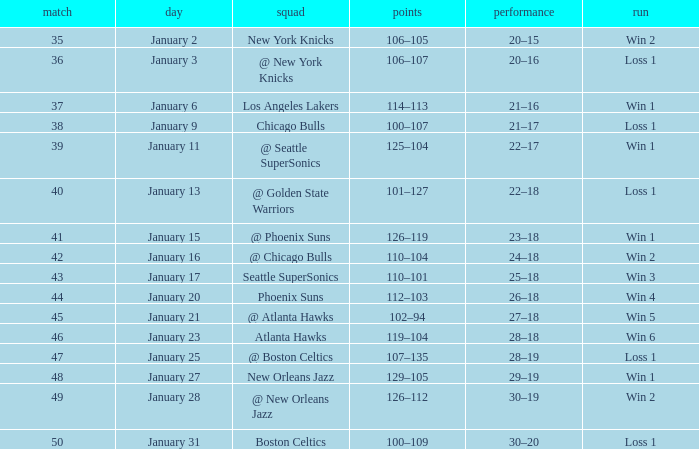What Game had a Score of 129–105? 48.0. Would you be able to parse every entry in this table? {'header': ['match', 'day', 'squad', 'points', 'performance', 'run'], 'rows': [['35', 'January 2', 'New York Knicks', '106–105', '20–15', 'Win 2'], ['36', 'January 3', '@ New York Knicks', '106–107', '20–16', 'Loss 1'], ['37', 'January 6', 'Los Angeles Lakers', '114–113', '21–16', 'Win 1'], ['38', 'January 9', 'Chicago Bulls', '100–107', '21–17', 'Loss 1'], ['39', 'January 11', '@ Seattle SuperSonics', '125–104', '22–17', 'Win 1'], ['40', 'January 13', '@ Golden State Warriors', '101–127', '22–18', 'Loss 1'], ['41', 'January 15', '@ Phoenix Suns', '126–119', '23–18', 'Win 1'], ['42', 'January 16', '@ Chicago Bulls', '110–104', '24–18', 'Win 2'], ['43', 'January 17', 'Seattle SuperSonics', '110–101', '25–18', 'Win 3'], ['44', 'January 20', 'Phoenix Suns', '112–103', '26–18', 'Win 4'], ['45', 'January 21', '@ Atlanta Hawks', '102–94', '27–18', 'Win 5'], ['46', 'January 23', 'Atlanta Hawks', '119–104', '28–18', 'Win 6'], ['47', 'January 25', '@ Boston Celtics', '107–135', '28–19', 'Loss 1'], ['48', 'January 27', 'New Orleans Jazz', '129–105', '29–19', 'Win 1'], ['49', 'January 28', '@ New Orleans Jazz', '126–112', '30–19', 'Win 2'], ['50', 'January 31', 'Boston Celtics', '100–109', '30–20', 'Loss 1']]} 